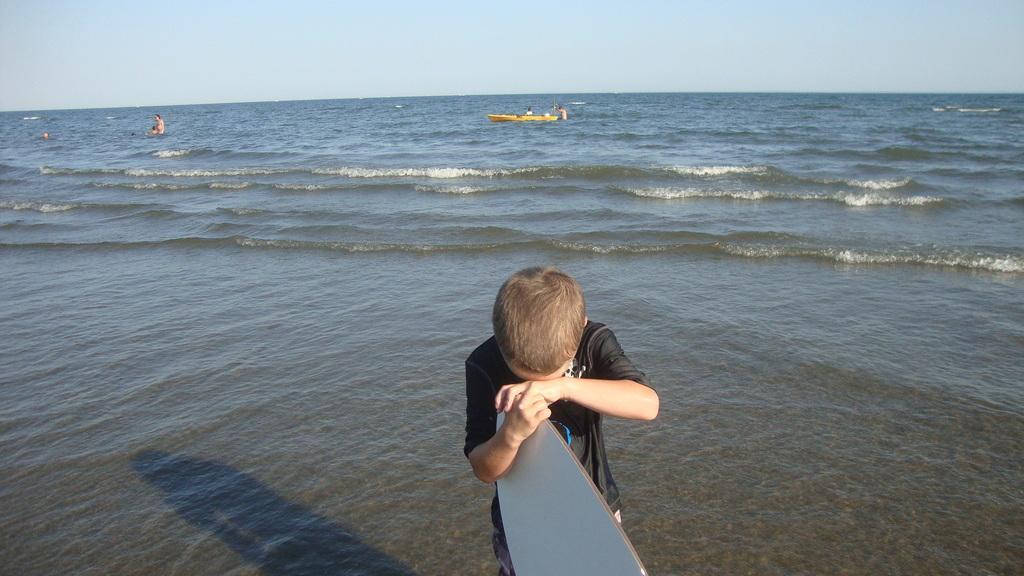How would you summarize this image in a sentence or two? This image is clicked outside. There are water is the image, there is sky on the top. there is there is a child standing in the front who is wearing black dress. He is holding something. 